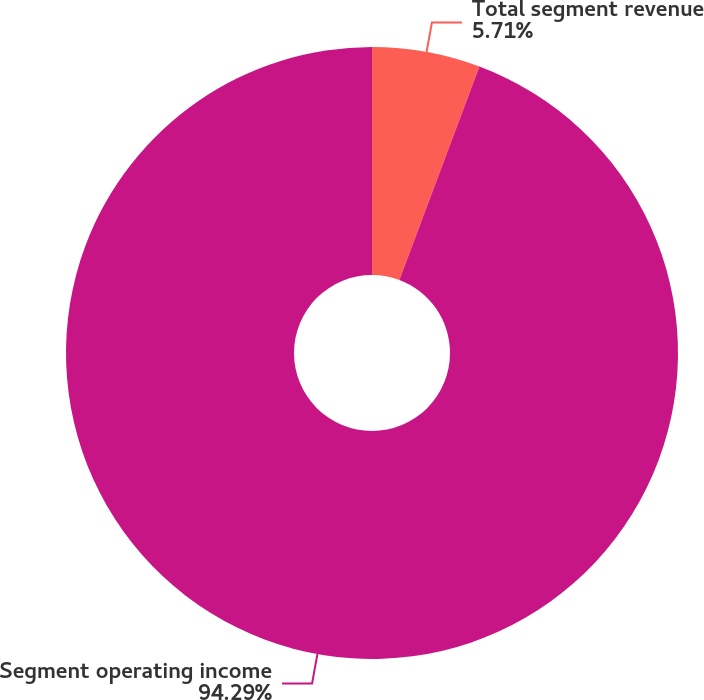<chart> <loc_0><loc_0><loc_500><loc_500><pie_chart><fcel>Total segment revenue<fcel>Segment operating income<nl><fcel>5.71%<fcel>94.29%<nl></chart> 